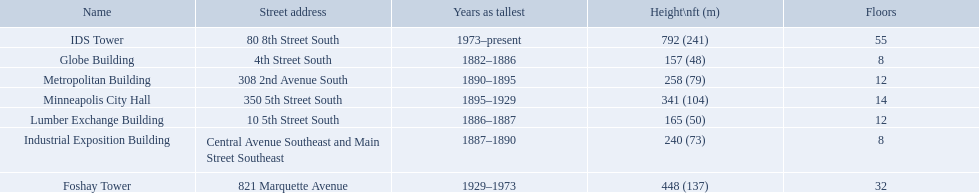Which buildings have the same number of floors as another building? Globe Building, Lumber Exchange Building, Industrial Exposition Building, Metropolitan Building. Of those, which has the same as the lumber exchange building? Metropolitan Building. How tall is the metropolitan building? 258 (79). How tall is the lumber exchange building? 165 (50). Is the metropolitan or lumber exchange building taller? Metropolitan Building. 